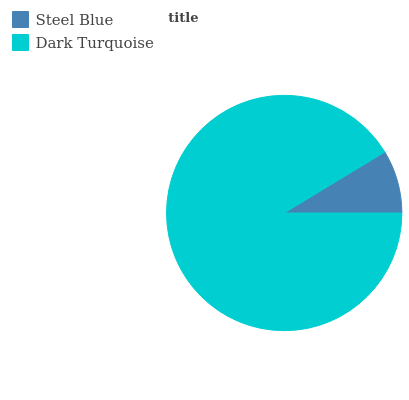Is Steel Blue the minimum?
Answer yes or no. Yes. Is Dark Turquoise the maximum?
Answer yes or no. Yes. Is Dark Turquoise the minimum?
Answer yes or no. No. Is Dark Turquoise greater than Steel Blue?
Answer yes or no. Yes. Is Steel Blue less than Dark Turquoise?
Answer yes or no. Yes. Is Steel Blue greater than Dark Turquoise?
Answer yes or no. No. Is Dark Turquoise less than Steel Blue?
Answer yes or no. No. Is Dark Turquoise the high median?
Answer yes or no. Yes. Is Steel Blue the low median?
Answer yes or no. Yes. Is Steel Blue the high median?
Answer yes or no. No. Is Dark Turquoise the low median?
Answer yes or no. No. 